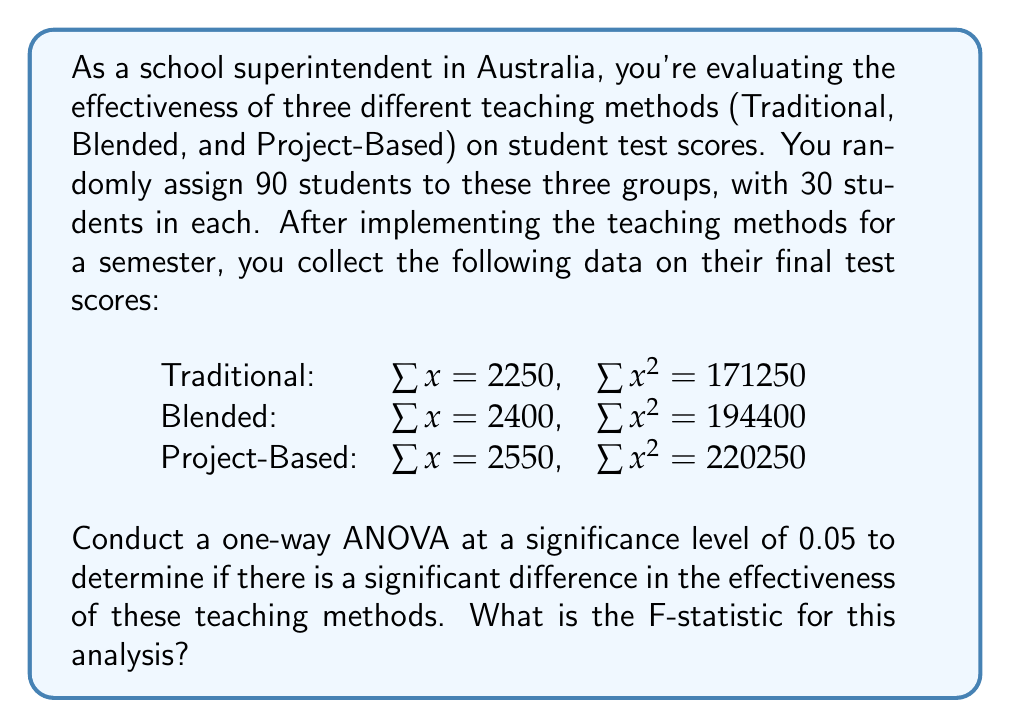Can you solve this math problem? To conduct a one-way ANOVA, we need to follow these steps:

1. Calculate the sum of squares total (SST), sum of squares between (SSB), and sum of squares within (SSW).
2. Calculate the degrees of freedom for between groups (dfB) and within groups (dfW).
3. Calculate the mean square between (MSB) and mean square within (MSW).
4. Calculate the F-statistic.

Step 1: Calculate SST, SSB, and SSW

First, let's calculate the total sum of squares (SST):
$$SST = \sum x^2 - \frac{(\sum x)^2}{N}$$

$\sum x^2 = 171250 + 194400 + 220250 = 585900$
$\sum x = 2250 + 2400 + 2550 = 7200$
$N = 90$

$$SST = 585900 - \frac{7200^2}{90} = 585900 - 576000 = 9900$$

Now, let's calculate the sum of squares between (SSB):
$$SSB = \sum \frac{T_i^2}{n_i} - \frac{(\sum x)^2}{N}$$

Where $T_i$ is the sum of scores for each group and $n_i$ is the number of scores in each group.

$$SSB = \frac{2250^2}{30} + \frac{2400^2}{30} + \frac{2550^2}{30} - \frac{7200^2}{90}$$
$$SSB = 168750 + 192000 + 216750 - 576000 = 1500$$

The sum of squares within (SSW) is the difference between SST and SSB:
$$SSW = SST - SSB = 9900 - 1500 = 8400$$

Step 2: Calculate degrees of freedom

dfB = number of groups - 1 = 3 - 1 = 2
dfW = N - number of groups = 90 - 3 = 87

Step 3: Calculate MSB and MSW

$$MSB = \frac{SSB}{dfB} = \frac{1500}{2} = 750$$
$$MSW = \frac{SSW}{dfW} = \frac{8400}{87} \approx 96.55$$

Step 4: Calculate the F-statistic

$$F = \frac{MSB}{MSW} = \frac{750}{96.55} \approx 7.77$$

Therefore, the F-statistic for this analysis is approximately 7.77.
Answer: 7.77 (rounded to two decimal places) 